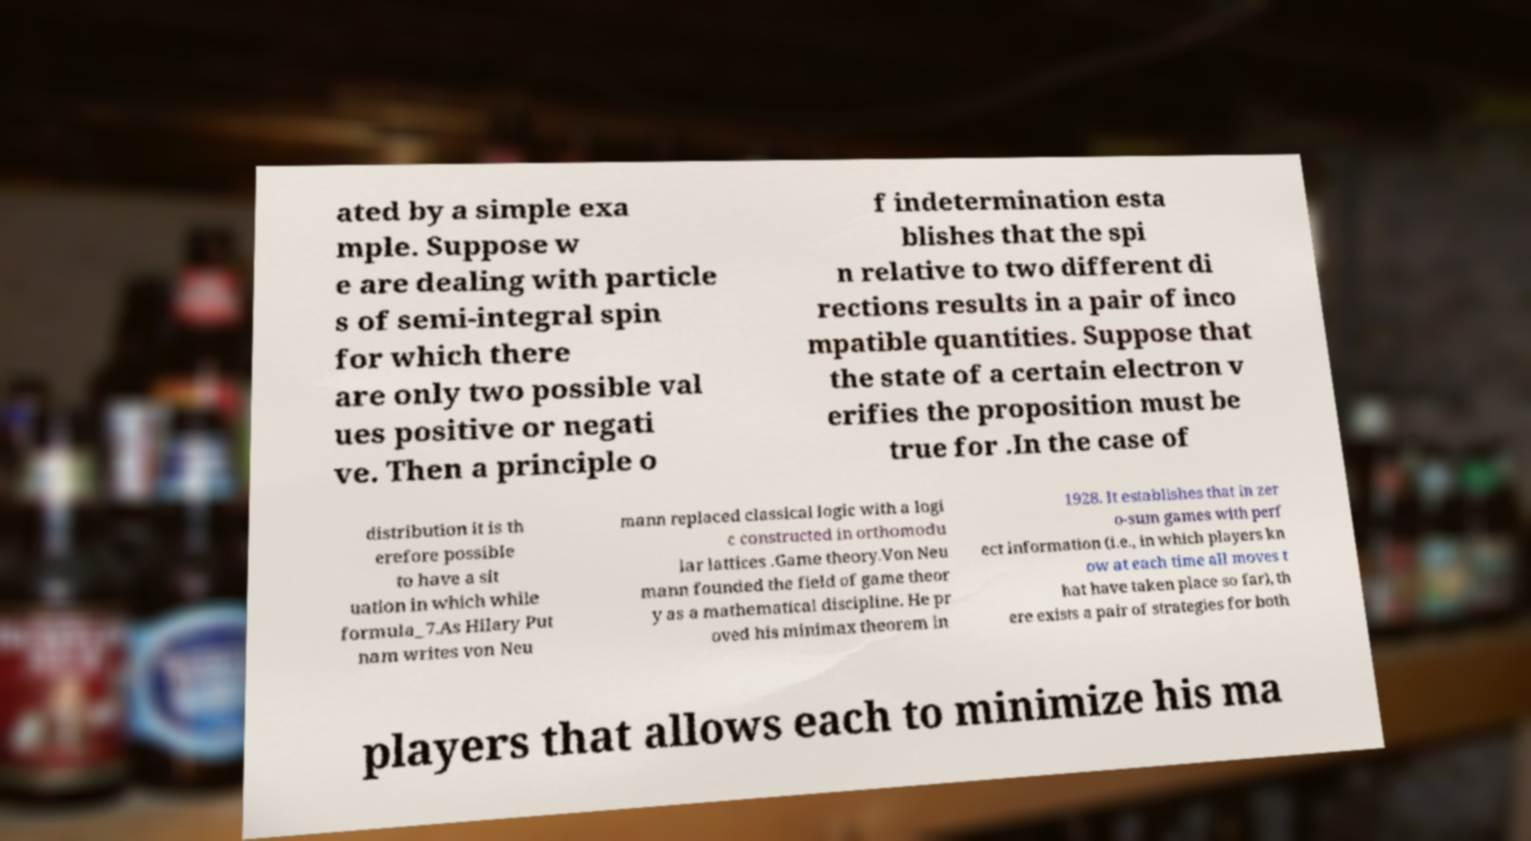Could you assist in decoding the text presented in this image and type it out clearly? ated by a simple exa mple. Suppose w e are dealing with particle s of semi-integral spin for which there are only two possible val ues positive or negati ve. Then a principle o f indetermination esta blishes that the spi n relative to two different di rections results in a pair of inco mpatible quantities. Suppose that the state of a certain electron v erifies the proposition must be true for .In the case of distribution it is th erefore possible to have a sit uation in which while formula_7.As Hilary Put nam writes von Neu mann replaced classical logic with a logi c constructed in orthomodu lar lattices .Game theory.Von Neu mann founded the field of game theor y as a mathematical discipline. He pr oved his minimax theorem in 1928. It establishes that in zer o-sum games with perf ect information (i.e., in which players kn ow at each time all moves t hat have taken place so far), th ere exists a pair of strategies for both players that allows each to minimize his ma 